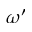<formula> <loc_0><loc_0><loc_500><loc_500>\omega ^ { \prime }</formula> 